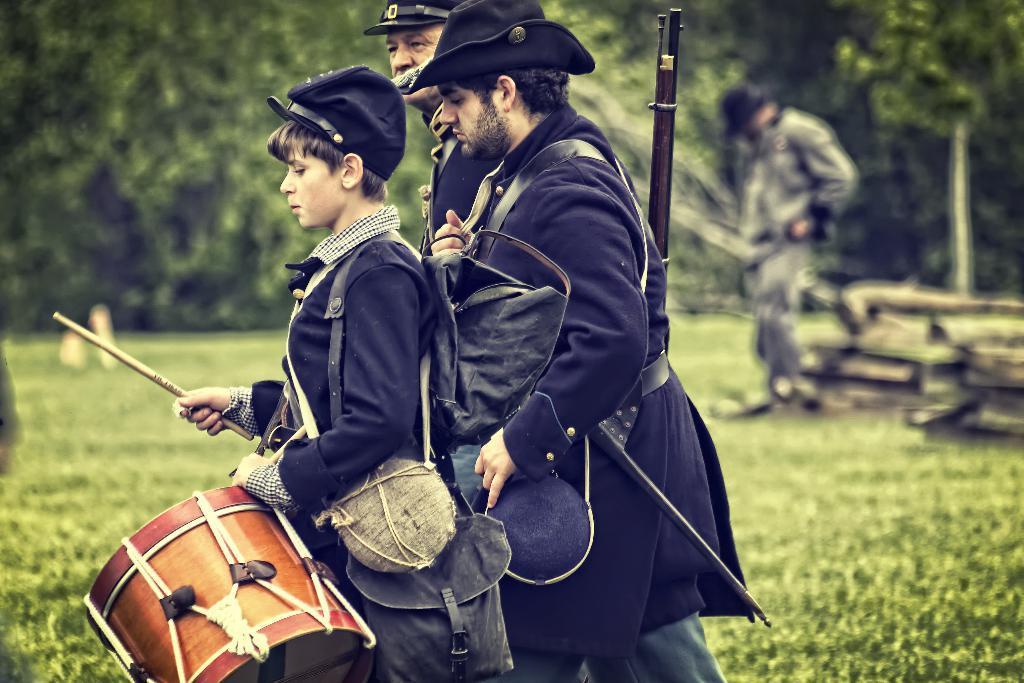Could you give a brief overview of what you see in this image? In this picture we can see two men and one woman holding drumsticks, caps in their hands and in background we can see trees some person standing, grass, wooden sticks. 